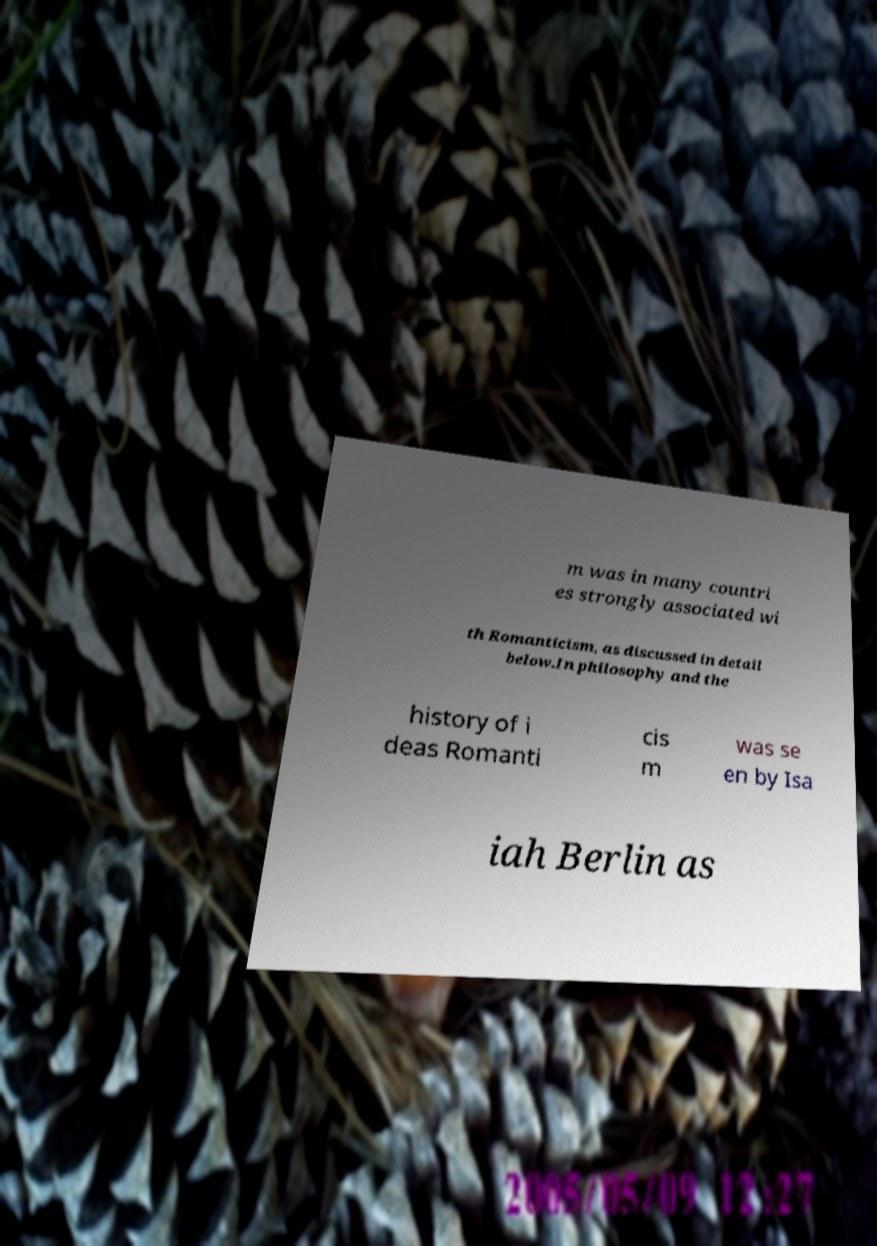I need the written content from this picture converted into text. Can you do that? m was in many countri es strongly associated wi th Romanticism, as discussed in detail below.In philosophy and the history of i deas Romanti cis m was se en by Isa iah Berlin as 